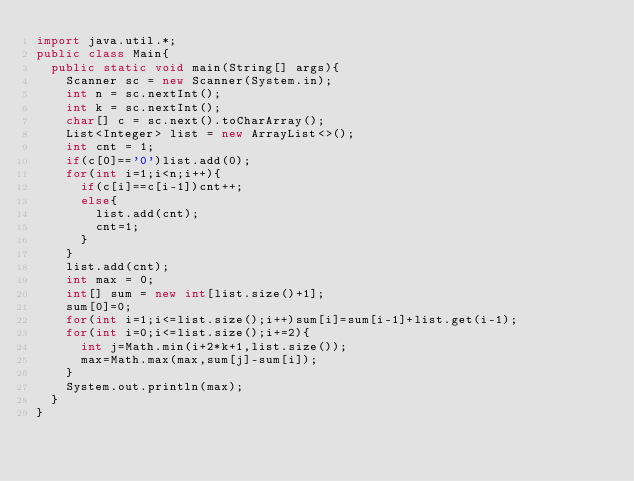Convert code to text. <code><loc_0><loc_0><loc_500><loc_500><_Java_>import java.util.*;
public class Main{
  public static void main(String[] args){
    Scanner sc = new Scanner(System.in);
    int n = sc.nextInt();
    int k = sc.nextInt();
    char[] c = sc.next().toCharArray();
    List<Integer> list = new ArrayList<>();
    int cnt = 1;
    if(c[0]=='0')list.add(0);
    for(int i=1;i<n;i++){
      if(c[i]==c[i-1])cnt++;
      else{
        list.add(cnt);
        cnt=1;
      }
    }
    list.add(cnt);
    int max = 0;
    int[] sum = new int[list.size()+1];
    sum[0]=0;
    for(int i=1;i<=list.size();i++)sum[i]=sum[i-1]+list.get(i-1);
    for(int i=0;i<=list.size();i+=2){
      int j=Math.min(i+2*k+1,list.size());
      max=Math.max(max,sum[j]-sum[i]);
    }
    System.out.println(max);
  }
}</code> 